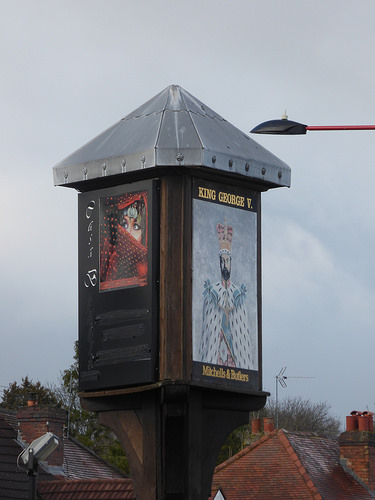<image>
Is the king george above the house? Yes. The king george is positioned above the house in the vertical space, higher up in the scene. 